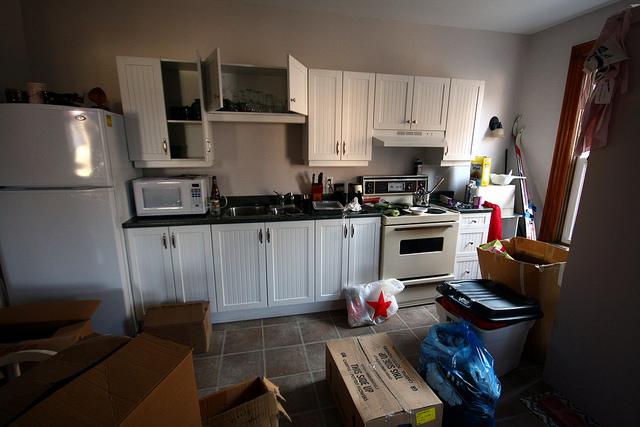How many cabinet doors are open?
Quick response, please. 3. Are the people that live here getting ready to move?
Concise answer only. Yes. What is this room called?
Quick response, please. Kitchen. What color are the appliances?
Give a very brief answer. White. Is this a toilet?
Write a very short answer. No. How many bags on the floor?
Be succinct. 2. Is it dark in this room?
Be succinct. No. Do you see a refrigerator in the picture?
Write a very short answer. Yes. Is the floor clean?
Answer briefly. No. What color is the trash bag?
Answer briefly. Blue. 